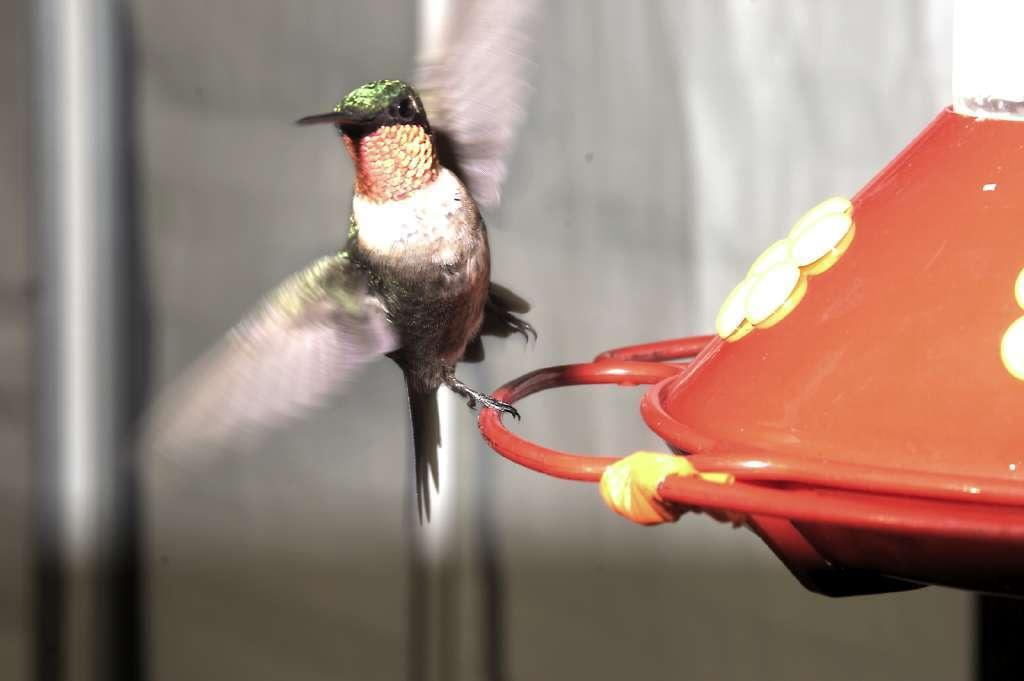What is the main subject of the image? There is an object in the image. Can you describe any living creatures in the image? There is a bird in the image. What can be seen in the background of the image? There are poles in the background of the image. How would you describe the quality of the image? The image is blurry. What type of book is the bird holding in the image? There is no book present in the image; it features a bird and an object, but no book. What kind of jewel is the skirt made of in the image? There is no skirt present in the image, and therefore no jewels associated with it. 